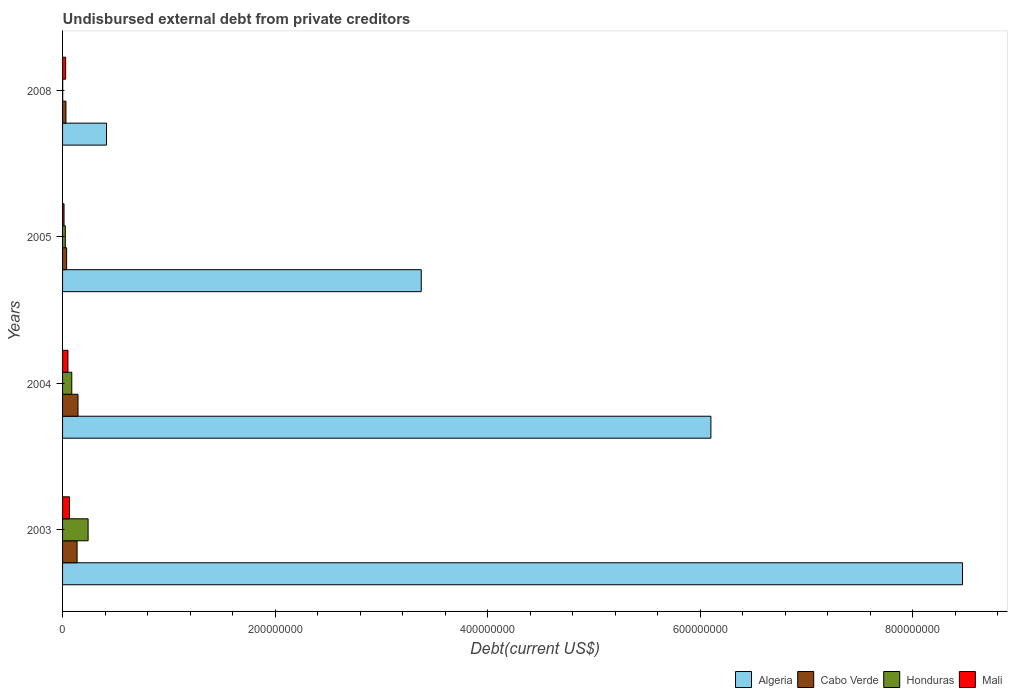Are the number of bars per tick equal to the number of legend labels?
Make the answer very short. Yes. How many bars are there on the 1st tick from the top?
Your response must be concise. 4. How many bars are there on the 4th tick from the bottom?
Make the answer very short. 4. What is the label of the 3rd group of bars from the top?
Your answer should be very brief. 2004. In how many cases, is the number of bars for a given year not equal to the number of legend labels?
Keep it short and to the point. 0. What is the total debt in Algeria in 2005?
Your answer should be very brief. 3.37e+08. Across all years, what is the maximum total debt in Cabo Verde?
Your response must be concise. 1.45e+07. Across all years, what is the minimum total debt in Algeria?
Offer a very short reply. 4.13e+07. In which year was the total debt in Algeria maximum?
Provide a succinct answer. 2003. In which year was the total debt in Cabo Verde minimum?
Give a very brief answer. 2008. What is the total total debt in Mali in the graph?
Your answer should be very brief. 1.59e+07. What is the difference between the total debt in Mali in 2004 and that in 2005?
Your answer should be compact. 3.68e+06. What is the difference between the total debt in Cabo Verde in 2005 and the total debt in Mali in 2008?
Offer a terse response. 9.11e+05. What is the average total debt in Algeria per year?
Offer a very short reply. 4.59e+08. In the year 2005, what is the difference between the total debt in Mali and total debt in Algeria?
Your response must be concise. -3.36e+08. What is the ratio of the total debt in Cabo Verde in 2003 to that in 2008?
Ensure brevity in your answer.  4.3. What is the difference between the highest and the second highest total debt in Algeria?
Your answer should be compact. 2.37e+08. What is the difference between the highest and the lowest total debt in Mali?
Make the answer very short. 5.14e+06. In how many years, is the total debt in Honduras greater than the average total debt in Honduras taken over all years?
Offer a terse response. 1. Is the sum of the total debt in Cabo Verde in 2004 and 2005 greater than the maximum total debt in Algeria across all years?
Offer a very short reply. No. What does the 2nd bar from the top in 2003 represents?
Offer a very short reply. Honduras. What does the 3rd bar from the bottom in 2005 represents?
Make the answer very short. Honduras. How many bars are there?
Your answer should be compact. 16. How many years are there in the graph?
Offer a terse response. 4. What is the difference between two consecutive major ticks on the X-axis?
Provide a succinct answer. 2.00e+08. Does the graph contain any zero values?
Provide a short and direct response. No. Does the graph contain grids?
Keep it short and to the point. No. What is the title of the graph?
Make the answer very short. Undisbursed external debt from private creditors. Does "Georgia" appear as one of the legend labels in the graph?
Ensure brevity in your answer.  No. What is the label or title of the X-axis?
Provide a short and direct response. Debt(current US$). What is the Debt(current US$) in Algeria in 2003?
Your answer should be compact. 8.47e+08. What is the Debt(current US$) of Cabo Verde in 2003?
Give a very brief answer. 1.37e+07. What is the Debt(current US$) of Honduras in 2003?
Provide a succinct answer. 2.40e+07. What is the Debt(current US$) in Mali in 2003?
Your answer should be very brief. 6.53e+06. What is the Debt(current US$) in Algeria in 2004?
Keep it short and to the point. 6.10e+08. What is the Debt(current US$) in Cabo Verde in 2004?
Ensure brevity in your answer.  1.45e+07. What is the Debt(current US$) of Honduras in 2004?
Give a very brief answer. 8.67e+06. What is the Debt(current US$) in Mali in 2004?
Offer a terse response. 5.06e+06. What is the Debt(current US$) in Algeria in 2005?
Your response must be concise. 3.37e+08. What is the Debt(current US$) of Cabo Verde in 2005?
Keep it short and to the point. 3.82e+06. What is the Debt(current US$) of Honduras in 2005?
Offer a terse response. 2.57e+06. What is the Debt(current US$) in Mali in 2005?
Provide a succinct answer. 1.38e+06. What is the Debt(current US$) of Algeria in 2008?
Your answer should be very brief. 4.13e+07. What is the Debt(current US$) of Cabo Verde in 2008?
Your response must be concise. 3.18e+06. What is the Debt(current US$) of Honduras in 2008?
Your answer should be very brief. 1.32e+05. What is the Debt(current US$) in Mali in 2008?
Ensure brevity in your answer.  2.91e+06. Across all years, what is the maximum Debt(current US$) of Algeria?
Your response must be concise. 8.47e+08. Across all years, what is the maximum Debt(current US$) of Cabo Verde?
Ensure brevity in your answer.  1.45e+07. Across all years, what is the maximum Debt(current US$) in Honduras?
Ensure brevity in your answer.  2.40e+07. Across all years, what is the maximum Debt(current US$) of Mali?
Ensure brevity in your answer.  6.53e+06. Across all years, what is the minimum Debt(current US$) of Algeria?
Your answer should be very brief. 4.13e+07. Across all years, what is the minimum Debt(current US$) in Cabo Verde?
Provide a succinct answer. 3.18e+06. Across all years, what is the minimum Debt(current US$) in Honduras?
Your answer should be compact. 1.32e+05. Across all years, what is the minimum Debt(current US$) in Mali?
Your response must be concise. 1.38e+06. What is the total Debt(current US$) of Algeria in the graph?
Your answer should be compact. 1.84e+09. What is the total Debt(current US$) of Cabo Verde in the graph?
Give a very brief answer. 3.52e+07. What is the total Debt(current US$) in Honduras in the graph?
Give a very brief answer. 3.54e+07. What is the total Debt(current US$) in Mali in the graph?
Make the answer very short. 1.59e+07. What is the difference between the Debt(current US$) in Algeria in 2003 and that in 2004?
Offer a very short reply. 2.37e+08. What is the difference between the Debt(current US$) of Cabo Verde in 2003 and that in 2004?
Provide a short and direct response. -8.61e+05. What is the difference between the Debt(current US$) of Honduras in 2003 and that in 2004?
Your response must be concise. 1.54e+07. What is the difference between the Debt(current US$) in Mali in 2003 and that in 2004?
Your answer should be very brief. 1.46e+06. What is the difference between the Debt(current US$) in Algeria in 2003 and that in 2005?
Keep it short and to the point. 5.09e+08. What is the difference between the Debt(current US$) in Cabo Verde in 2003 and that in 2005?
Offer a very short reply. 9.85e+06. What is the difference between the Debt(current US$) of Honduras in 2003 and that in 2005?
Give a very brief answer. 2.15e+07. What is the difference between the Debt(current US$) in Mali in 2003 and that in 2005?
Provide a short and direct response. 5.14e+06. What is the difference between the Debt(current US$) in Algeria in 2003 and that in 2008?
Keep it short and to the point. 8.05e+08. What is the difference between the Debt(current US$) in Cabo Verde in 2003 and that in 2008?
Ensure brevity in your answer.  1.05e+07. What is the difference between the Debt(current US$) in Honduras in 2003 and that in 2008?
Your response must be concise. 2.39e+07. What is the difference between the Debt(current US$) in Mali in 2003 and that in 2008?
Provide a succinct answer. 3.62e+06. What is the difference between the Debt(current US$) in Algeria in 2004 and that in 2005?
Your response must be concise. 2.73e+08. What is the difference between the Debt(current US$) of Cabo Verde in 2004 and that in 2005?
Ensure brevity in your answer.  1.07e+07. What is the difference between the Debt(current US$) in Honduras in 2004 and that in 2005?
Offer a terse response. 6.10e+06. What is the difference between the Debt(current US$) in Mali in 2004 and that in 2005?
Your answer should be compact. 3.68e+06. What is the difference between the Debt(current US$) of Algeria in 2004 and that in 2008?
Give a very brief answer. 5.69e+08. What is the difference between the Debt(current US$) in Cabo Verde in 2004 and that in 2008?
Give a very brief answer. 1.14e+07. What is the difference between the Debt(current US$) in Honduras in 2004 and that in 2008?
Your answer should be compact. 8.54e+06. What is the difference between the Debt(current US$) of Mali in 2004 and that in 2008?
Provide a short and direct response. 2.16e+06. What is the difference between the Debt(current US$) in Algeria in 2005 and that in 2008?
Keep it short and to the point. 2.96e+08. What is the difference between the Debt(current US$) in Cabo Verde in 2005 and that in 2008?
Offer a terse response. 6.39e+05. What is the difference between the Debt(current US$) in Honduras in 2005 and that in 2008?
Your answer should be compact. 2.44e+06. What is the difference between the Debt(current US$) in Mali in 2005 and that in 2008?
Give a very brief answer. -1.52e+06. What is the difference between the Debt(current US$) of Algeria in 2003 and the Debt(current US$) of Cabo Verde in 2004?
Offer a terse response. 8.32e+08. What is the difference between the Debt(current US$) of Algeria in 2003 and the Debt(current US$) of Honduras in 2004?
Your answer should be compact. 8.38e+08. What is the difference between the Debt(current US$) in Algeria in 2003 and the Debt(current US$) in Mali in 2004?
Your answer should be very brief. 8.42e+08. What is the difference between the Debt(current US$) of Cabo Verde in 2003 and the Debt(current US$) of Honduras in 2004?
Provide a succinct answer. 5.00e+06. What is the difference between the Debt(current US$) in Cabo Verde in 2003 and the Debt(current US$) in Mali in 2004?
Offer a terse response. 8.61e+06. What is the difference between the Debt(current US$) of Honduras in 2003 and the Debt(current US$) of Mali in 2004?
Provide a succinct answer. 1.90e+07. What is the difference between the Debt(current US$) in Algeria in 2003 and the Debt(current US$) in Cabo Verde in 2005?
Your answer should be compact. 8.43e+08. What is the difference between the Debt(current US$) of Algeria in 2003 and the Debt(current US$) of Honduras in 2005?
Ensure brevity in your answer.  8.44e+08. What is the difference between the Debt(current US$) in Algeria in 2003 and the Debt(current US$) in Mali in 2005?
Keep it short and to the point. 8.45e+08. What is the difference between the Debt(current US$) of Cabo Verde in 2003 and the Debt(current US$) of Honduras in 2005?
Your answer should be very brief. 1.11e+07. What is the difference between the Debt(current US$) of Cabo Verde in 2003 and the Debt(current US$) of Mali in 2005?
Offer a terse response. 1.23e+07. What is the difference between the Debt(current US$) in Honduras in 2003 and the Debt(current US$) in Mali in 2005?
Make the answer very short. 2.27e+07. What is the difference between the Debt(current US$) of Algeria in 2003 and the Debt(current US$) of Cabo Verde in 2008?
Offer a very short reply. 8.44e+08. What is the difference between the Debt(current US$) of Algeria in 2003 and the Debt(current US$) of Honduras in 2008?
Give a very brief answer. 8.47e+08. What is the difference between the Debt(current US$) of Algeria in 2003 and the Debt(current US$) of Mali in 2008?
Offer a terse response. 8.44e+08. What is the difference between the Debt(current US$) in Cabo Verde in 2003 and the Debt(current US$) in Honduras in 2008?
Give a very brief answer. 1.35e+07. What is the difference between the Debt(current US$) in Cabo Verde in 2003 and the Debt(current US$) in Mali in 2008?
Ensure brevity in your answer.  1.08e+07. What is the difference between the Debt(current US$) of Honduras in 2003 and the Debt(current US$) of Mali in 2008?
Provide a succinct answer. 2.11e+07. What is the difference between the Debt(current US$) of Algeria in 2004 and the Debt(current US$) of Cabo Verde in 2005?
Provide a succinct answer. 6.06e+08. What is the difference between the Debt(current US$) in Algeria in 2004 and the Debt(current US$) in Honduras in 2005?
Ensure brevity in your answer.  6.07e+08. What is the difference between the Debt(current US$) of Algeria in 2004 and the Debt(current US$) of Mali in 2005?
Give a very brief answer. 6.09e+08. What is the difference between the Debt(current US$) in Cabo Verde in 2004 and the Debt(current US$) in Honduras in 2005?
Ensure brevity in your answer.  1.20e+07. What is the difference between the Debt(current US$) in Cabo Verde in 2004 and the Debt(current US$) in Mali in 2005?
Make the answer very short. 1.31e+07. What is the difference between the Debt(current US$) in Honduras in 2004 and the Debt(current US$) in Mali in 2005?
Your answer should be compact. 7.29e+06. What is the difference between the Debt(current US$) of Algeria in 2004 and the Debt(current US$) of Cabo Verde in 2008?
Provide a succinct answer. 6.07e+08. What is the difference between the Debt(current US$) in Algeria in 2004 and the Debt(current US$) in Honduras in 2008?
Your answer should be very brief. 6.10e+08. What is the difference between the Debt(current US$) in Algeria in 2004 and the Debt(current US$) in Mali in 2008?
Offer a terse response. 6.07e+08. What is the difference between the Debt(current US$) of Cabo Verde in 2004 and the Debt(current US$) of Honduras in 2008?
Offer a terse response. 1.44e+07. What is the difference between the Debt(current US$) of Cabo Verde in 2004 and the Debt(current US$) of Mali in 2008?
Keep it short and to the point. 1.16e+07. What is the difference between the Debt(current US$) of Honduras in 2004 and the Debt(current US$) of Mali in 2008?
Make the answer very short. 5.76e+06. What is the difference between the Debt(current US$) of Algeria in 2005 and the Debt(current US$) of Cabo Verde in 2008?
Provide a short and direct response. 3.34e+08. What is the difference between the Debt(current US$) in Algeria in 2005 and the Debt(current US$) in Honduras in 2008?
Keep it short and to the point. 3.37e+08. What is the difference between the Debt(current US$) in Algeria in 2005 and the Debt(current US$) in Mali in 2008?
Keep it short and to the point. 3.35e+08. What is the difference between the Debt(current US$) in Cabo Verde in 2005 and the Debt(current US$) in Honduras in 2008?
Give a very brief answer. 3.69e+06. What is the difference between the Debt(current US$) in Cabo Verde in 2005 and the Debt(current US$) in Mali in 2008?
Offer a very short reply. 9.11e+05. What is the difference between the Debt(current US$) of Honduras in 2005 and the Debt(current US$) of Mali in 2008?
Your answer should be very brief. -3.40e+05. What is the average Debt(current US$) in Algeria per year?
Your answer should be compact. 4.59e+08. What is the average Debt(current US$) in Cabo Verde per year?
Provide a short and direct response. 8.80e+06. What is the average Debt(current US$) of Honduras per year?
Give a very brief answer. 8.85e+06. What is the average Debt(current US$) in Mali per year?
Give a very brief answer. 3.97e+06. In the year 2003, what is the difference between the Debt(current US$) of Algeria and Debt(current US$) of Cabo Verde?
Make the answer very short. 8.33e+08. In the year 2003, what is the difference between the Debt(current US$) of Algeria and Debt(current US$) of Honduras?
Provide a short and direct response. 8.23e+08. In the year 2003, what is the difference between the Debt(current US$) in Algeria and Debt(current US$) in Mali?
Offer a very short reply. 8.40e+08. In the year 2003, what is the difference between the Debt(current US$) of Cabo Verde and Debt(current US$) of Honduras?
Your response must be concise. -1.04e+07. In the year 2003, what is the difference between the Debt(current US$) in Cabo Verde and Debt(current US$) in Mali?
Ensure brevity in your answer.  7.14e+06. In the year 2003, what is the difference between the Debt(current US$) in Honduras and Debt(current US$) in Mali?
Offer a very short reply. 1.75e+07. In the year 2004, what is the difference between the Debt(current US$) in Algeria and Debt(current US$) in Cabo Verde?
Ensure brevity in your answer.  5.95e+08. In the year 2004, what is the difference between the Debt(current US$) of Algeria and Debt(current US$) of Honduras?
Your answer should be compact. 6.01e+08. In the year 2004, what is the difference between the Debt(current US$) in Algeria and Debt(current US$) in Mali?
Your response must be concise. 6.05e+08. In the year 2004, what is the difference between the Debt(current US$) of Cabo Verde and Debt(current US$) of Honduras?
Offer a terse response. 5.86e+06. In the year 2004, what is the difference between the Debt(current US$) in Cabo Verde and Debt(current US$) in Mali?
Make the answer very short. 9.47e+06. In the year 2004, what is the difference between the Debt(current US$) in Honduras and Debt(current US$) in Mali?
Your answer should be very brief. 3.61e+06. In the year 2005, what is the difference between the Debt(current US$) in Algeria and Debt(current US$) in Cabo Verde?
Your answer should be compact. 3.34e+08. In the year 2005, what is the difference between the Debt(current US$) of Algeria and Debt(current US$) of Honduras?
Offer a terse response. 3.35e+08. In the year 2005, what is the difference between the Debt(current US$) of Algeria and Debt(current US$) of Mali?
Offer a terse response. 3.36e+08. In the year 2005, what is the difference between the Debt(current US$) of Cabo Verde and Debt(current US$) of Honduras?
Ensure brevity in your answer.  1.25e+06. In the year 2005, what is the difference between the Debt(current US$) of Cabo Verde and Debt(current US$) of Mali?
Make the answer very short. 2.43e+06. In the year 2005, what is the difference between the Debt(current US$) in Honduras and Debt(current US$) in Mali?
Your answer should be compact. 1.18e+06. In the year 2008, what is the difference between the Debt(current US$) of Algeria and Debt(current US$) of Cabo Verde?
Your answer should be compact. 3.82e+07. In the year 2008, what is the difference between the Debt(current US$) in Algeria and Debt(current US$) in Honduras?
Offer a terse response. 4.12e+07. In the year 2008, what is the difference between the Debt(current US$) of Algeria and Debt(current US$) of Mali?
Make the answer very short. 3.84e+07. In the year 2008, what is the difference between the Debt(current US$) in Cabo Verde and Debt(current US$) in Honduras?
Keep it short and to the point. 3.05e+06. In the year 2008, what is the difference between the Debt(current US$) in Cabo Verde and Debt(current US$) in Mali?
Your answer should be compact. 2.72e+05. In the year 2008, what is the difference between the Debt(current US$) of Honduras and Debt(current US$) of Mali?
Your response must be concise. -2.78e+06. What is the ratio of the Debt(current US$) of Algeria in 2003 to that in 2004?
Keep it short and to the point. 1.39. What is the ratio of the Debt(current US$) of Cabo Verde in 2003 to that in 2004?
Your response must be concise. 0.94. What is the ratio of the Debt(current US$) in Honduras in 2003 to that in 2004?
Offer a very short reply. 2.77. What is the ratio of the Debt(current US$) of Mali in 2003 to that in 2004?
Give a very brief answer. 1.29. What is the ratio of the Debt(current US$) in Algeria in 2003 to that in 2005?
Your answer should be very brief. 2.51. What is the ratio of the Debt(current US$) in Cabo Verde in 2003 to that in 2005?
Keep it short and to the point. 3.58. What is the ratio of the Debt(current US$) in Honduras in 2003 to that in 2005?
Provide a short and direct response. 9.36. What is the ratio of the Debt(current US$) of Mali in 2003 to that in 2005?
Your response must be concise. 4.71. What is the ratio of the Debt(current US$) in Algeria in 2003 to that in 2008?
Offer a terse response. 20.48. What is the ratio of the Debt(current US$) in Cabo Verde in 2003 to that in 2008?
Your answer should be very brief. 4.3. What is the ratio of the Debt(current US$) in Honduras in 2003 to that in 2008?
Your answer should be very brief. 182.1. What is the ratio of the Debt(current US$) in Mali in 2003 to that in 2008?
Make the answer very short. 2.24. What is the ratio of the Debt(current US$) of Algeria in 2004 to that in 2005?
Your response must be concise. 1.81. What is the ratio of the Debt(current US$) in Cabo Verde in 2004 to that in 2005?
Your response must be concise. 3.8. What is the ratio of the Debt(current US$) of Honduras in 2004 to that in 2005?
Your answer should be compact. 3.38. What is the ratio of the Debt(current US$) of Mali in 2004 to that in 2005?
Provide a succinct answer. 3.66. What is the ratio of the Debt(current US$) of Algeria in 2004 to that in 2008?
Your answer should be very brief. 14.75. What is the ratio of the Debt(current US$) in Cabo Verde in 2004 to that in 2008?
Offer a terse response. 4.57. What is the ratio of the Debt(current US$) of Honduras in 2004 to that in 2008?
Provide a short and direct response. 65.7. What is the ratio of the Debt(current US$) in Mali in 2004 to that in 2008?
Offer a terse response. 1.74. What is the ratio of the Debt(current US$) of Algeria in 2005 to that in 2008?
Offer a terse response. 8.16. What is the ratio of the Debt(current US$) in Cabo Verde in 2005 to that in 2008?
Your answer should be very brief. 1.2. What is the ratio of the Debt(current US$) in Honduras in 2005 to that in 2008?
Ensure brevity in your answer.  19.45. What is the ratio of the Debt(current US$) of Mali in 2005 to that in 2008?
Your answer should be very brief. 0.48. What is the difference between the highest and the second highest Debt(current US$) in Algeria?
Provide a short and direct response. 2.37e+08. What is the difference between the highest and the second highest Debt(current US$) in Cabo Verde?
Offer a terse response. 8.61e+05. What is the difference between the highest and the second highest Debt(current US$) of Honduras?
Your answer should be very brief. 1.54e+07. What is the difference between the highest and the second highest Debt(current US$) of Mali?
Your answer should be compact. 1.46e+06. What is the difference between the highest and the lowest Debt(current US$) in Algeria?
Offer a very short reply. 8.05e+08. What is the difference between the highest and the lowest Debt(current US$) of Cabo Verde?
Offer a very short reply. 1.14e+07. What is the difference between the highest and the lowest Debt(current US$) in Honduras?
Your response must be concise. 2.39e+07. What is the difference between the highest and the lowest Debt(current US$) of Mali?
Your response must be concise. 5.14e+06. 